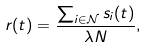Convert formula to latex. <formula><loc_0><loc_0><loc_500><loc_500>r ( t ) = \frac { \sum _ { i \in { \mathcal { N } } } s _ { i } ( t ) } { \lambda N } ,</formula> 